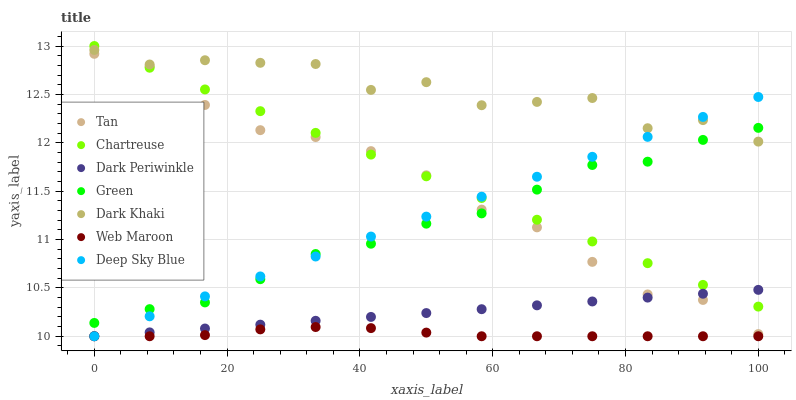Does Web Maroon have the minimum area under the curve?
Answer yes or no. Yes. Does Dark Khaki have the maximum area under the curve?
Answer yes or no. Yes. Does Chartreuse have the minimum area under the curve?
Answer yes or no. No. Does Chartreuse have the maximum area under the curve?
Answer yes or no. No. Is Deep Sky Blue the smoothest?
Answer yes or no. Yes. Is Dark Khaki the roughest?
Answer yes or no. Yes. Is Chartreuse the smoothest?
Answer yes or no. No. Is Chartreuse the roughest?
Answer yes or no. No. Does Web Maroon have the lowest value?
Answer yes or no. Yes. Does Chartreuse have the lowest value?
Answer yes or no. No. Does Chartreuse have the highest value?
Answer yes or no. Yes. Does Dark Khaki have the highest value?
Answer yes or no. No. Is Dark Periwinkle less than Green?
Answer yes or no. Yes. Is Chartreuse greater than Web Maroon?
Answer yes or no. Yes. Does Web Maroon intersect Dark Periwinkle?
Answer yes or no. Yes. Is Web Maroon less than Dark Periwinkle?
Answer yes or no. No. Is Web Maroon greater than Dark Periwinkle?
Answer yes or no. No. Does Dark Periwinkle intersect Green?
Answer yes or no. No. 